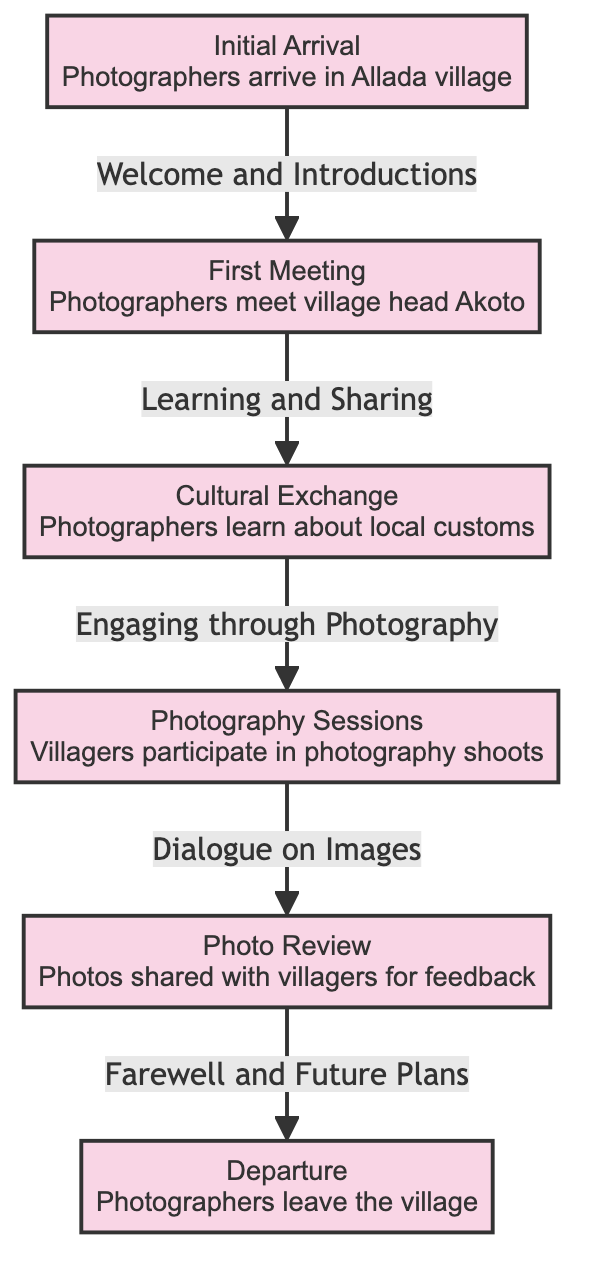What is the first node in the diagram? The first node in the diagram is "Initial Arrival" where photographers arrive in Allada village.
Answer: Initial Arrival How many nodes are there in the diagram? Counting all the labeled nodes in the diagram, there are a total of six distinct nodes.
Answer: 6 What relationship does the first node have with the second node? The relationship between the first node "Initial Arrival" and the second node "First Meeting" is described as "Welcome and Introductions," indicating a connective dialogue.
Answer: Welcome and Introductions What happens after the "Cultural Exchange" node? After the "Cultural Exchange" node, the next event is "Photography Sessions," where villagers participate in photography shoots.
Answer: Photography Sessions Which node follows the "Photo Review"? The node that follows "Photo Review" is "Departure," marking the end of the photographers' stay in the village.
Answer: Departure How does the "First Meeting" node relate to the "Cultural Exchange"? The "First Meeting" node relates to the "Cultural Exchange" by involving "Learning and Sharing," enhancing mutual understanding between photographers and villagers.
Answer: Learning and Sharing What is the last interaction noted in the diagram? The last interaction noted in the diagram is "Departure," where the photographers leave the village.
Answer: Departure How many edges are there flowing into the "Photo Review" node? There is one edge flowing into the "Photo Review" node, connecting it from the "Photography Sessions" node.
Answer: 1 What key action is described in the "Photography Sessions" node? The key action described in the "Photography Sessions" node is that villagers participate in photography shoots with the photographers.
Answer: Villagers participate in photography shoots 